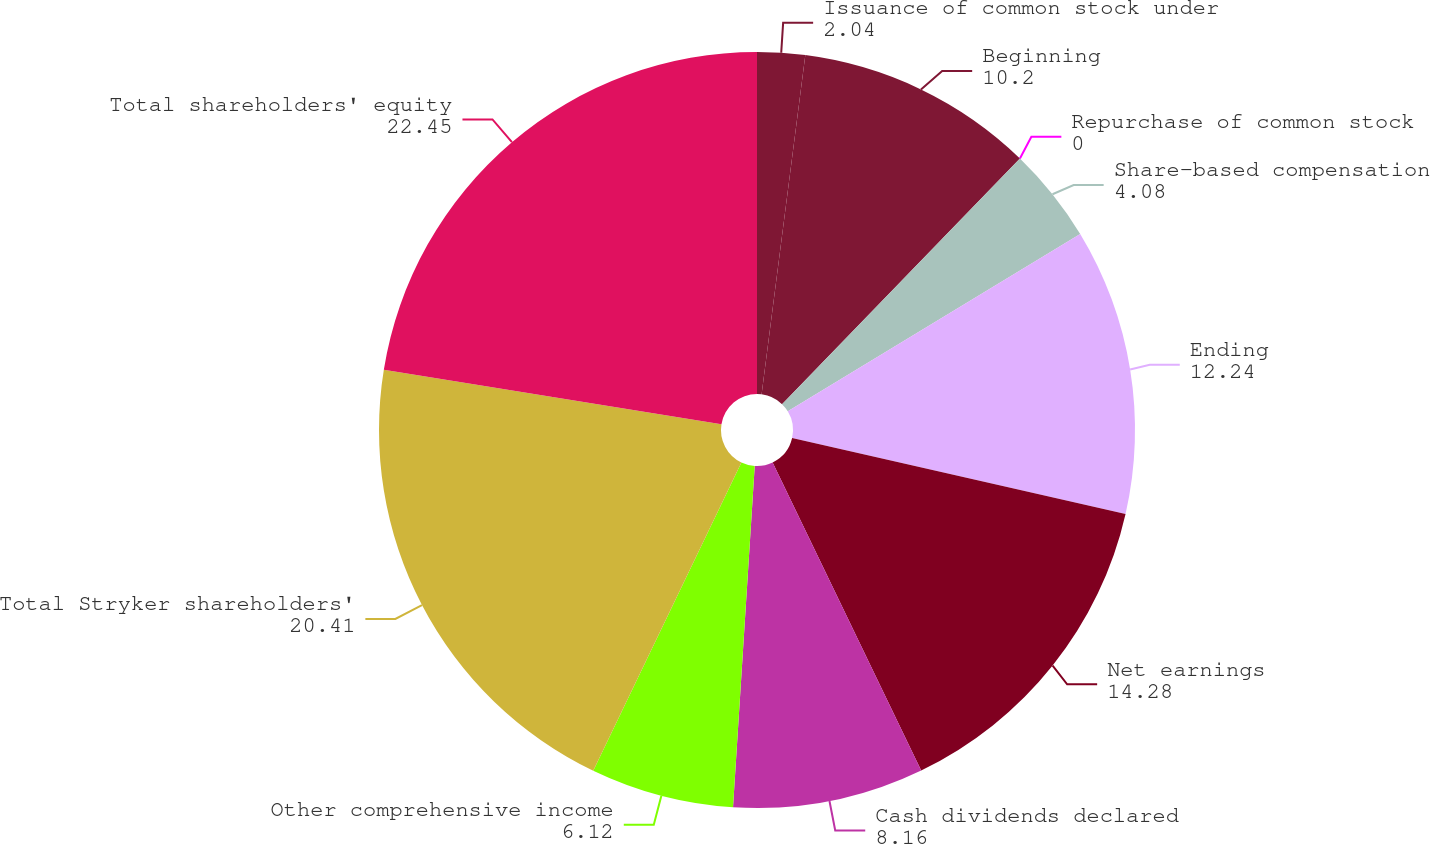Convert chart to OTSL. <chart><loc_0><loc_0><loc_500><loc_500><pie_chart><fcel>Issuance of common stock under<fcel>Beginning<fcel>Repurchase of common stock<fcel>Share-based compensation<fcel>Ending<fcel>Net earnings<fcel>Cash dividends declared<fcel>Other comprehensive income<fcel>Total Stryker shareholders'<fcel>Total shareholders' equity<nl><fcel>2.04%<fcel>10.2%<fcel>0.0%<fcel>4.08%<fcel>12.24%<fcel>14.28%<fcel>8.16%<fcel>6.12%<fcel>20.41%<fcel>22.45%<nl></chart> 